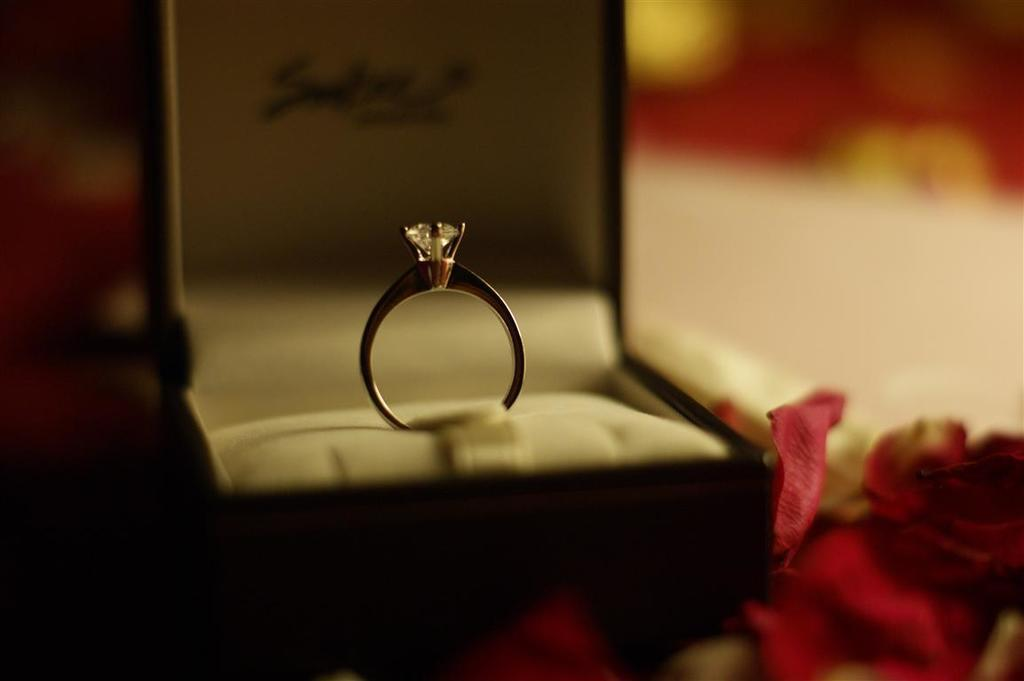What object is in the box that is visible in the image? There is a ring in the box that is visible in the image. What other items can be seen in the image besides the ring? There are rose petals visible in the image. Can you describe the background of the image? The background of the image is blurry. What type of iron can be seen in the image? There is no iron present in the image. How much money is visible in the image? There is no money present in the image. 